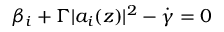Convert formula to latex. <formula><loc_0><loc_0><loc_500><loc_500>\beta _ { i } + \Gamma | a _ { i } ( z ) | ^ { 2 } - \dot { \gamma } = 0</formula> 